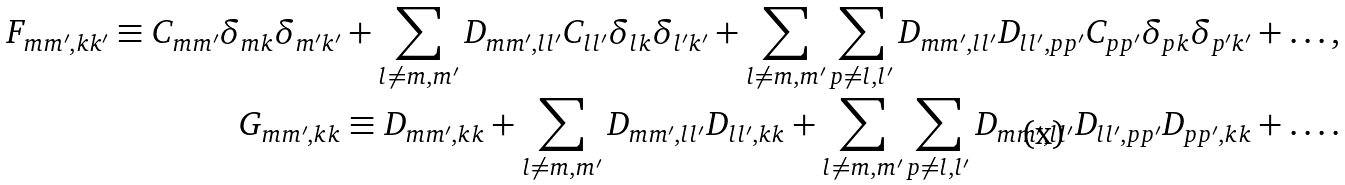Convert formula to latex. <formula><loc_0><loc_0><loc_500><loc_500>F _ { m m ^ { \prime } , k k ^ { \prime } } \equiv C _ { m m ^ { \prime } } \delta _ { m k } \delta _ { m ^ { \prime } k ^ { \prime } } + \sum _ { l \ne m , m ^ { \prime } } D _ { m m ^ { \prime } , l l ^ { \prime } } C _ { l l ^ { \prime } } \delta _ { l k } \delta _ { l ^ { \prime } k ^ { \prime } } + \sum _ { l \ne m , m ^ { \prime } } \sum _ { p \ne l , l ^ { \prime } } D _ { m m ^ { \prime } , l l ^ { \prime } } D _ { l l ^ { \prime } , p p ^ { \prime } } C _ { p p ^ { \prime } } \delta _ { p k } \delta _ { p ^ { \prime } k ^ { \prime } } + \dots , \\ G _ { m m ^ { \prime } , k k } \equiv D _ { m m ^ { \prime } , k k } + \sum _ { l \ne m , m ^ { \prime } } D _ { m m ^ { \prime } , l l ^ { \prime } } D _ { l l ^ { \prime } , k k } + \sum _ { l \ne m , m ^ { \prime } } \sum _ { p \ne l , l ^ { \prime } } D _ { m m ^ { \prime } , l l ^ { \prime } } D _ { l l ^ { \prime } , p p ^ { \prime } } D _ { p p ^ { \prime } , k k } + \dots .</formula> 